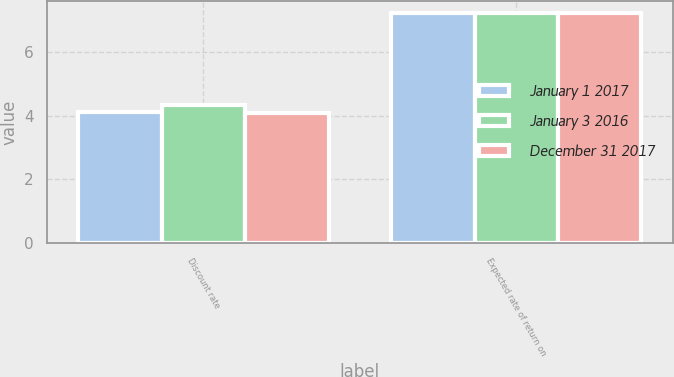Convert chart to OTSL. <chart><loc_0><loc_0><loc_500><loc_500><stacked_bar_chart><ecel><fcel>Discount rate<fcel>Expected rate of return on<nl><fcel>January 1 2017<fcel>4.11<fcel>7.25<nl><fcel>January 3 2016<fcel>4.34<fcel>7.25<nl><fcel>December 31 2017<fcel>4.1<fcel>7.25<nl></chart> 